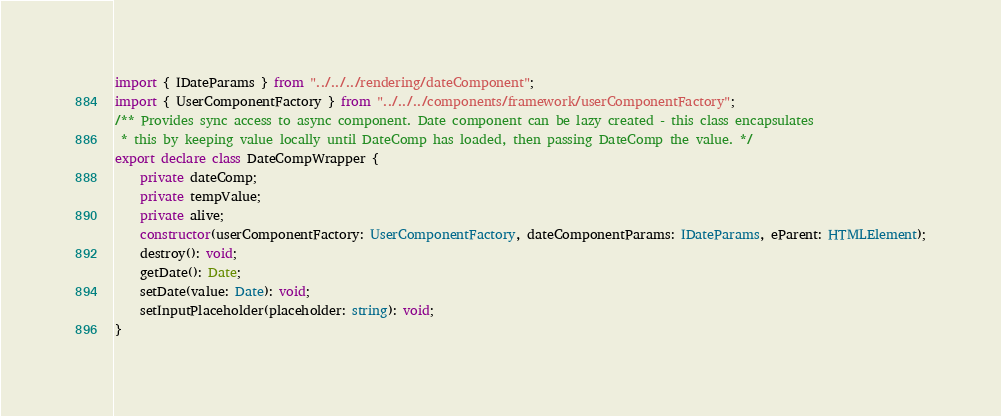Convert code to text. <code><loc_0><loc_0><loc_500><loc_500><_TypeScript_>import { IDateParams } from "../../../rendering/dateComponent";
import { UserComponentFactory } from "../../../components/framework/userComponentFactory";
/** Provides sync access to async component. Date component can be lazy created - this class encapsulates
 * this by keeping value locally until DateComp has loaded, then passing DateComp the value. */
export declare class DateCompWrapper {
    private dateComp;
    private tempValue;
    private alive;
    constructor(userComponentFactory: UserComponentFactory, dateComponentParams: IDateParams, eParent: HTMLElement);
    destroy(): void;
    getDate(): Date;
    setDate(value: Date): void;
    setInputPlaceholder(placeholder: string): void;
}
</code> 